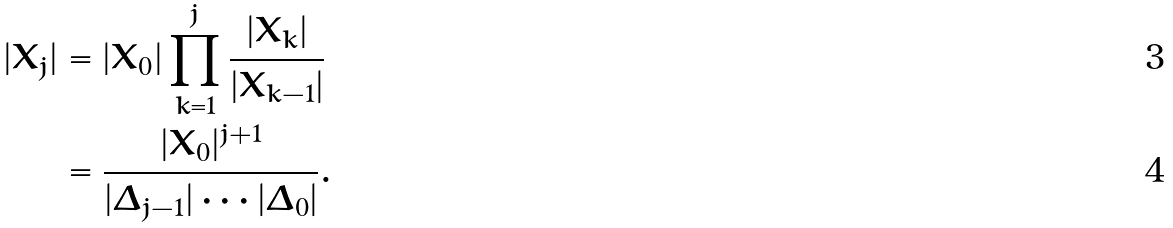<formula> <loc_0><loc_0><loc_500><loc_500>| X _ { j } | & = | X _ { 0 } | \prod _ { k = 1 } ^ { j } \frac { | X _ { k } | } { | X _ { k - 1 } | } \\ & = \frac { | X _ { 0 } | ^ { j + 1 } } { | \Delta _ { j - 1 } | \cdots | \Delta _ { 0 } | } .</formula> 